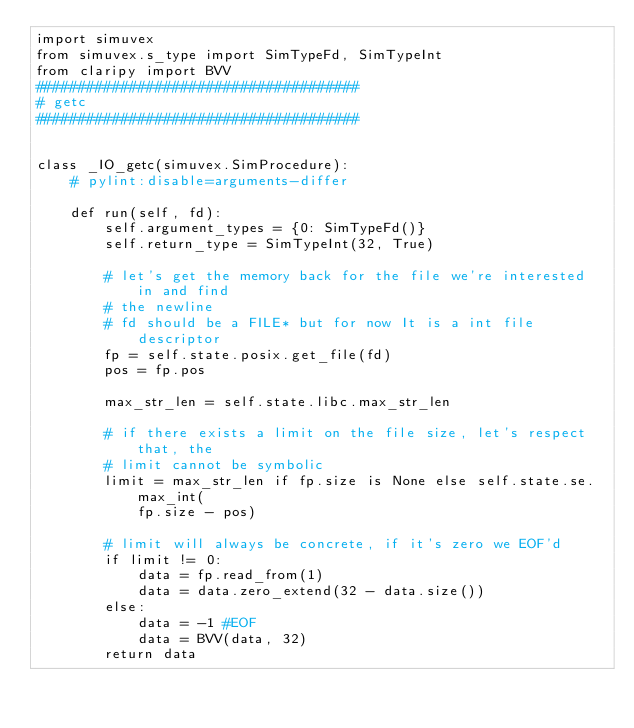Convert code to text. <code><loc_0><loc_0><loc_500><loc_500><_Python_>import simuvex
from simuvex.s_type import SimTypeFd, SimTypeInt
from claripy import BVV
######################################
# getc
######################################


class _IO_getc(simuvex.SimProcedure):
    # pylint:disable=arguments-differ

    def run(self, fd):
        self.argument_types = {0: SimTypeFd()}
        self.return_type = SimTypeInt(32, True)

        # let's get the memory back for the file we're interested in and find
        # the newline
        # fd should be a FILE* but for now It is a int file descriptor
        fp = self.state.posix.get_file(fd)
        pos = fp.pos

        max_str_len = self.state.libc.max_str_len

        # if there exists a limit on the file size, let's respect that, the
        # limit cannot be symbolic
        limit = max_str_len if fp.size is None else self.state.se.max_int(
            fp.size - pos)

        # limit will always be concrete, if it's zero we EOF'd
        if limit != 0:
            data = fp.read_from(1)
            data = data.zero_extend(32 - data.size())
        else:
            data = -1 #EOF
            data = BVV(data, 32)
        return data
</code> 